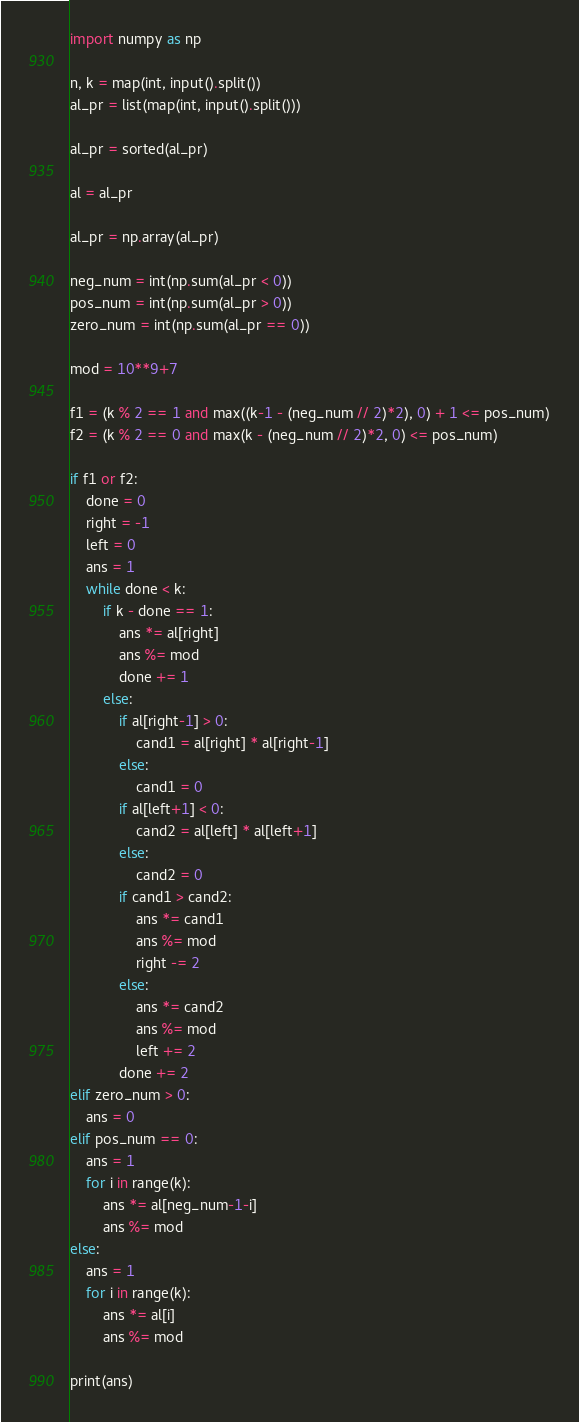Convert code to text. <code><loc_0><loc_0><loc_500><loc_500><_Python_>import numpy as np

n, k = map(int, input().split())
al_pr = list(map(int, input().split()))

al_pr = sorted(al_pr)

al = al_pr

al_pr = np.array(al_pr)

neg_num = int(np.sum(al_pr < 0))
pos_num = int(np.sum(al_pr > 0))
zero_num = int(np.sum(al_pr == 0))

mod = 10**9+7

f1 = (k % 2 == 1 and max((k-1 - (neg_num // 2)*2), 0) + 1 <= pos_num)
f2 = (k % 2 == 0 and max(k - (neg_num // 2)*2, 0) <= pos_num)

if f1 or f2:
    done = 0
    right = -1
    left = 0
    ans = 1
    while done < k:
        if k - done == 1:
            ans *= al[right]
            ans %= mod
            done += 1
        else:
            if al[right-1] > 0:
                cand1 = al[right] * al[right-1]
            else:
                cand1 = 0
            if al[left+1] < 0:
                cand2 = al[left] * al[left+1]
            else:
                cand2 = 0
            if cand1 > cand2:
                ans *= cand1
                ans %= mod
                right -= 2
            else:
                ans *= cand2
                ans %= mod
                left += 2
            done += 2
elif zero_num > 0:
    ans = 0
elif pos_num == 0:
    ans = 1
    for i in range(k):
        ans *= al[neg_num-1-i]
        ans %= mod
else:
    ans = 1
    for i in range(k):
        ans *= al[i]
        ans %= mod

print(ans)
</code> 